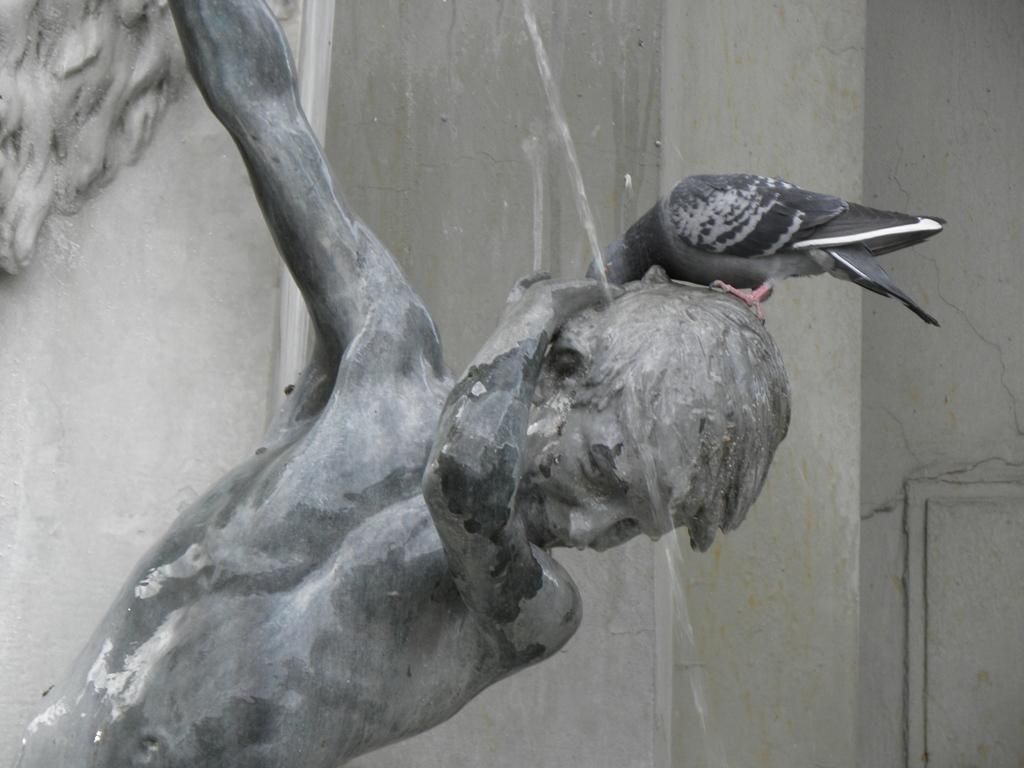What is the main subject of the image? There is a statue of a person in the image. Is there anything on the statue? Yes, a pigeon is on the statue. What can be seen in the background of the image? There is a wall in the background of the image. Can you hear the root of the goat in the image? There is no goat or sound present in the image, so it is not possible to hear the root of a goat. 